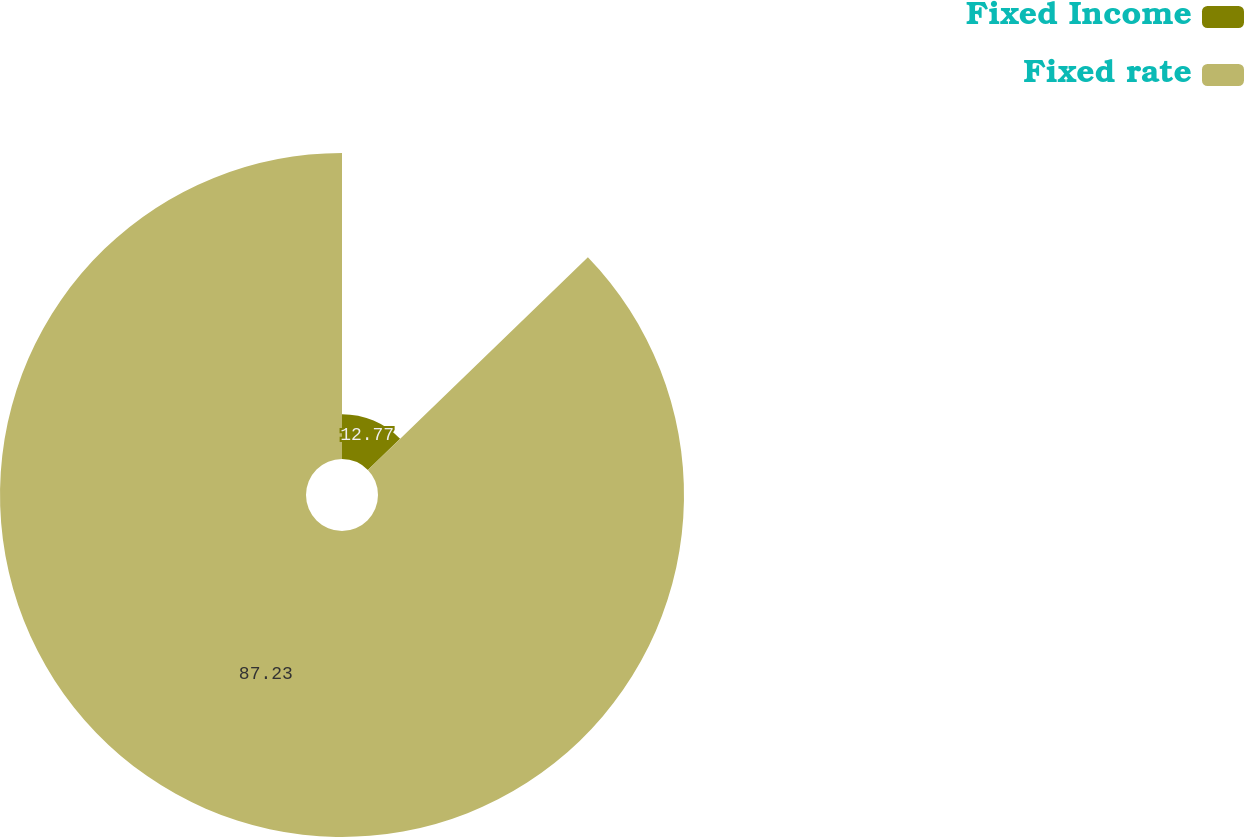Convert chart. <chart><loc_0><loc_0><loc_500><loc_500><pie_chart><fcel>Fixed Income<fcel>Fixed rate<nl><fcel>12.77%<fcel>87.23%<nl></chart> 